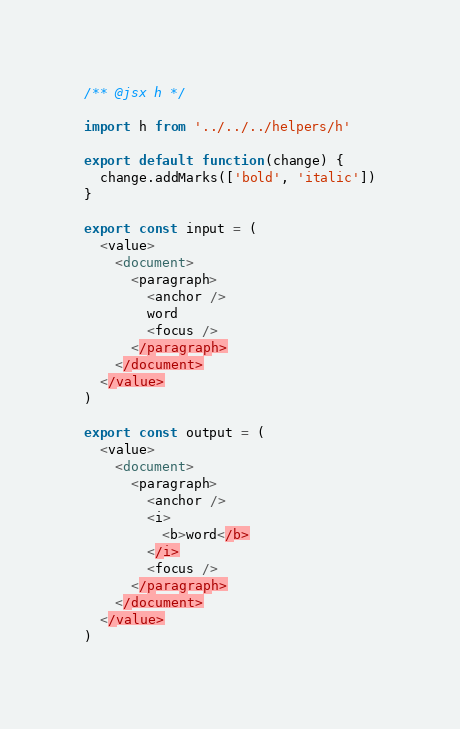Convert code to text. <code><loc_0><loc_0><loc_500><loc_500><_JavaScript_>/** @jsx h */

import h from '../../../helpers/h'

export default function(change) {
  change.addMarks(['bold', 'italic'])
}

export const input = (
  <value>
    <document>
      <paragraph>
        <anchor />
        word
        <focus />
      </paragraph>
    </document>
  </value>
)

export const output = (
  <value>
    <document>
      <paragraph>
        <anchor />
        <i>
          <b>word</b>
        </i>
        <focus />
      </paragraph>
    </document>
  </value>
)
</code> 